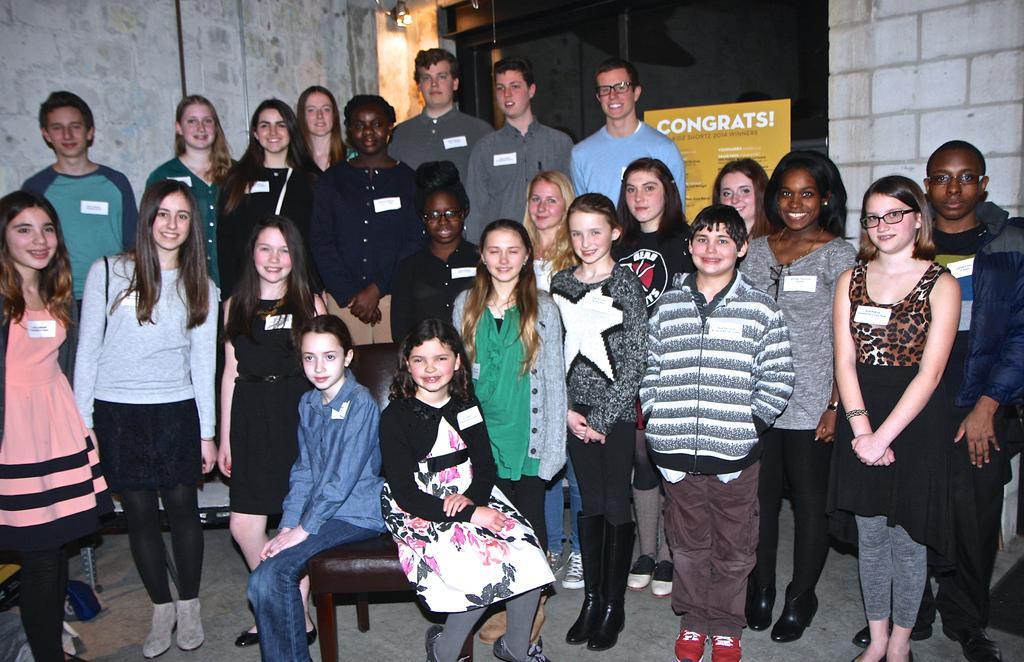Please provide a concise description of this image. In the image we can see there are many people standing, they are wearing clothes, shoes and some of them are wearing spectacles, there are two children sitting on the chair. There is a wall and a poster, this is a footpath and a light. These people are smiling and this is a white sticker. 